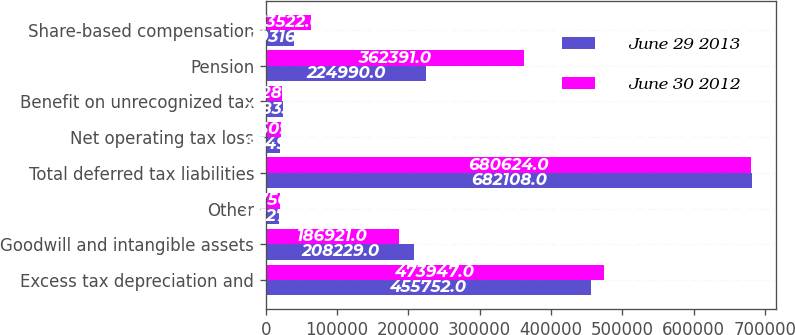Convert chart to OTSL. <chart><loc_0><loc_0><loc_500><loc_500><stacked_bar_chart><ecel><fcel>Excess tax depreciation and<fcel>Goodwill and intangible assets<fcel>Other<fcel>Total deferred tax liabilities<fcel>Net operating tax loss<fcel>Benefit on unrecognized tax<fcel>Pension<fcel>Share-based compensation<nl><fcel>June 29 2013<fcel>455752<fcel>208229<fcel>18127<fcel>682108<fcel>19149<fcel>23833<fcel>224990<fcel>39316<nl><fcel>June 30 2012<fcel>473947<fcel>186921<fcel>19756<fcel>680624<fcel>21609<fcel>23287<fcel>362391<fcel>63522<nl></chart> 